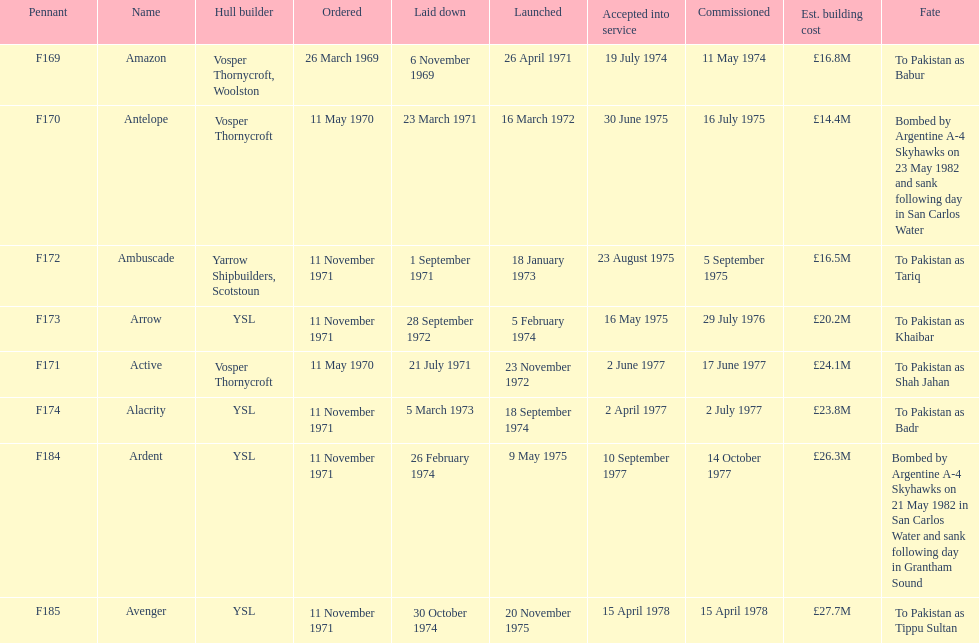How many boats were constructed for less than £20 million? 3. 